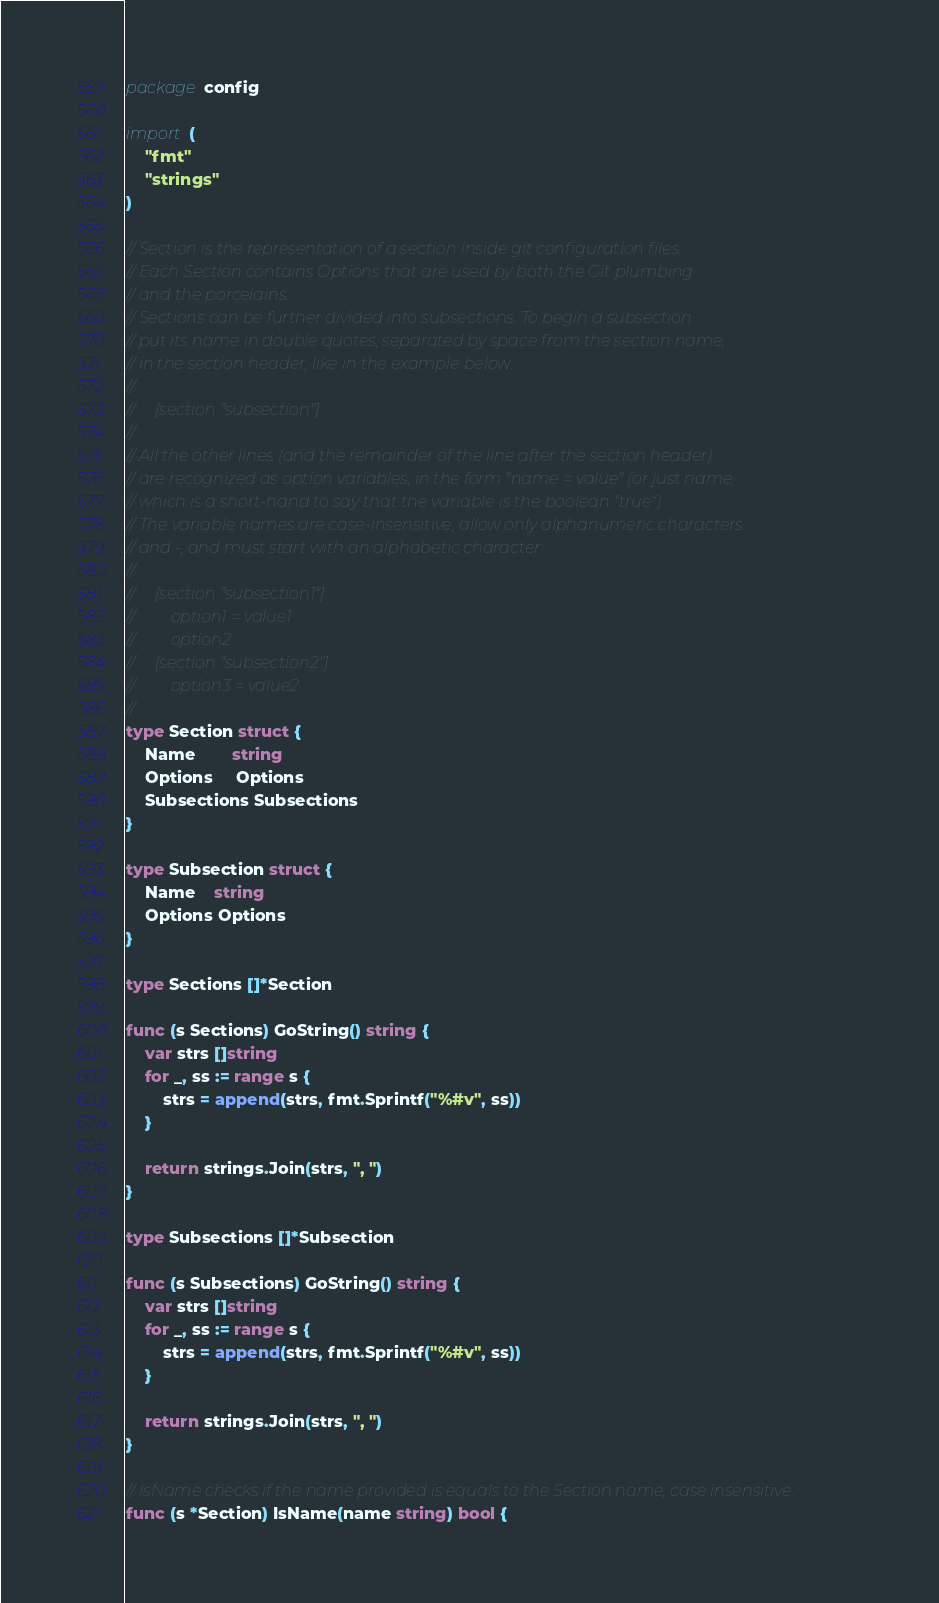<code> <loc_0><loc_0><loc_500><loc_500><_Go_>package config

import (
	"fmt"
	"strings"
)

// Section is the representation of a section inside git configuration files.
// Each Section contains Options that are used by both the Git plumbing
// and the porcelains.
// Sections can be further divided into subsections. To begin a subsection
// put its name in double quotes, separated by space from the section name,
// in the section header, like in the example below:
//
//     [section "subsection"]
//
// All the other lines (and the remainder of the line after the section header)
// are recognized as option variables, in the form "name = value" (or just name,
// which is a short-hand to say that the variable is the boolean "true").
// The variable names are case-insensitive, allow only alphanumeric characters
// and -, and must start with an alphabetic character:
//
//     [section "subsection1"]
//         option1 = value1
//         option2
//     [section "subsection2"]
//         option3 = value2
//
type Section struct {
	Name        string
	Options     Options
	Subsections Subsections
}

type Subsection struct {
	Name    string
	Options Options
}

type Sections []*Section

func (s Sections) GoString() string {
	var strs []string
	for _, ss := range s {
		strs = append(strs, fmt.Sprintf("%#v", ss))
	}

	return strings.Join(strs, ", ")
}

type Subsections []*Subsection

func (s Subsections) GoString() string {
	var strs []string
	for _, ss := range s {
		strs = append(strs, fmt.Sprintf("%#v", ss))
	}

	return strings.Join(strs, ", ")
}

// IsName checks if the name provided is equals to the Section name, case insensitive.
func (s *Section) IsName(name string) bool {</code> 